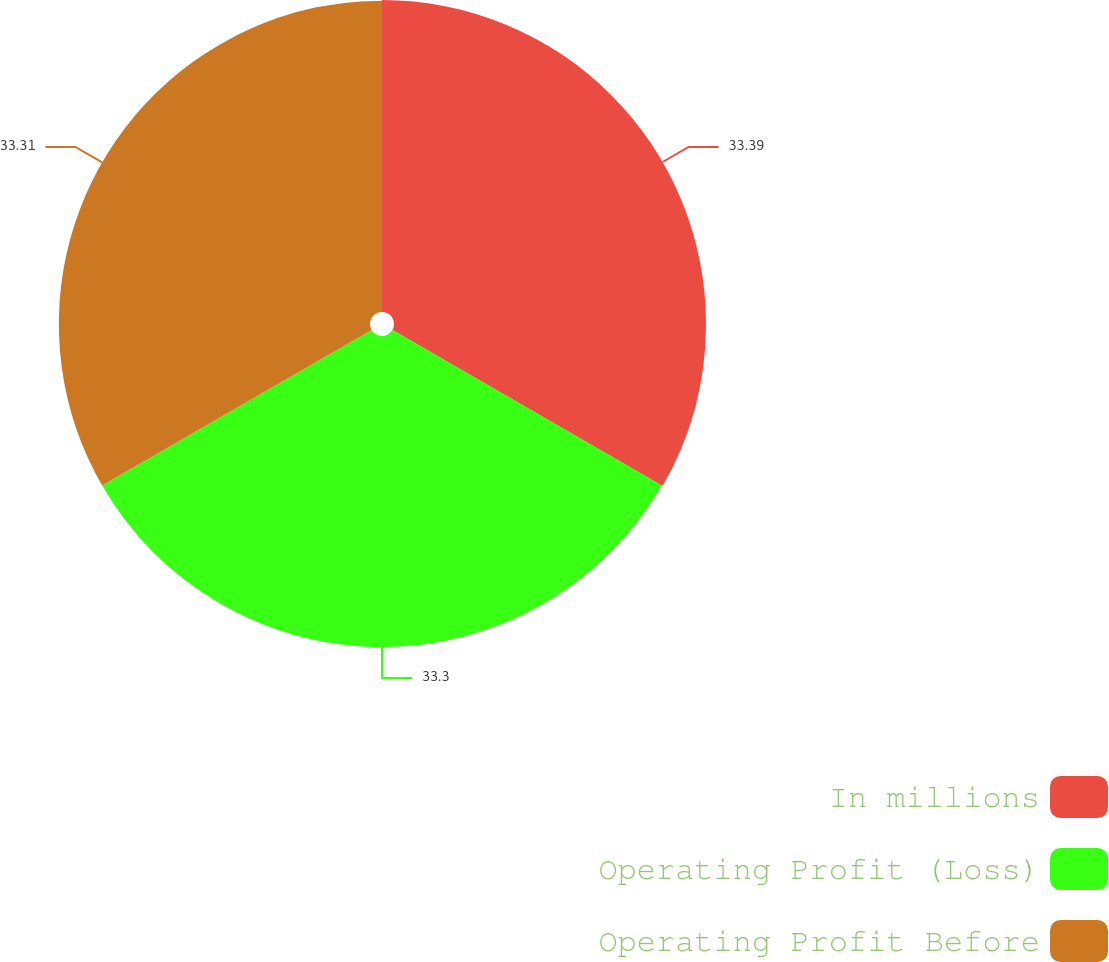Convert chart to OTSL. <chart><loc_0><loc_0><loc_500><loc_500><pie_chart><fcel>In millions<fcel>Operating Profit (Loss)<fcel>Operating Profit Before<nl><fcel>33.4%<fcel>33.3%<fcel>33.31%<nl></chart> 